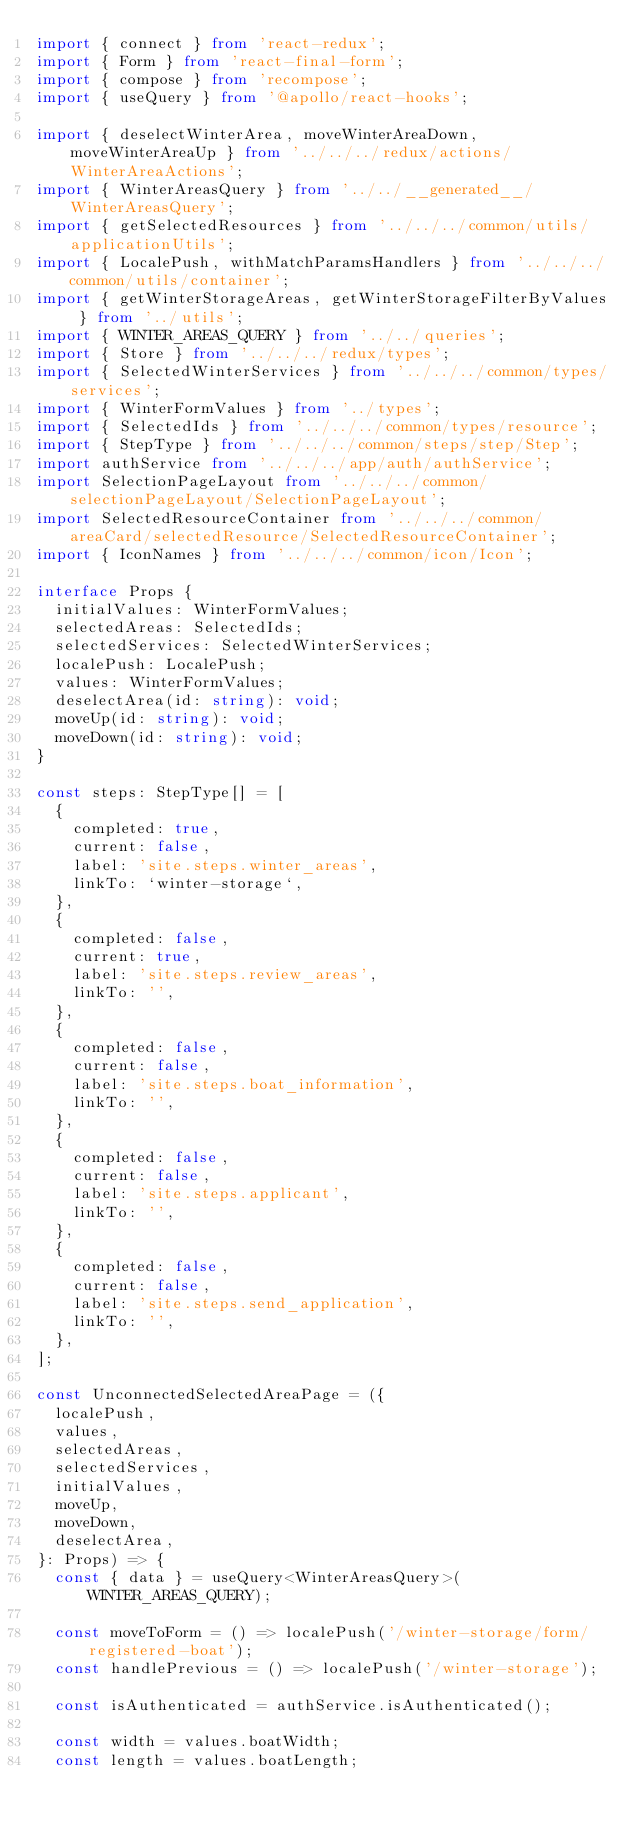Convert code to text. <code><loc_0><loc_0><loc_500><loc_500><_TypeScript_>import { connect } from 'react-redux';
import { Form } from 'react-final-form';
import { compose } from 'recompose';
import { useQuery } from '@apollo/react-hooks';

import { deselectWinterArea, moveWinterAreaDown, moveWinterAreaUp } from '../../../redux/actions/WinterAreaActions';
import { WinterAreasQuery } from '../../__generated__/WinterAreasQuery';
import { getSelectedResources } from '../../../common/utils/applicationUtils';
import { LocalePush, withMatchParamsHandlers } from '../../../common/utils/container';
import { getWinterStorageAreas, getWinterStorageFilterByValues } from '../utils';
import { WINTER_AREAS_QUERY } from '../../queries';
import { Store } from '../../../redux/types';
import { SelectedWinterServices } from '../../../common/types/services';
import { WinterFormValues } from '../types';
import { SelectedIds } from '../../../common/types/resource';
import { StepType } from '../../../common/steps/step/Step';
import authService from '../../../app/auth/authService';
import SelectionPageLayout from '../../../common/selectionPageLayout/SelectionPageLayout';
import SelectedResourceContainer from '../../../common/areaCard/selectedResource/SelectedResourceContainer';
import { IconNames } from '../../../common/icon/Icon';

interface Props {
  initialValues: WinterFormValues;
  selectedAreas: SelectedIds;
  selectedServices: SelectedWinterServices;
  localePush: LocalePush;
  values: WinterFormValues;
  deselectArea(id: string): void;
  moveUp(id: string): void;
  moveDown(id: string): void;
}

const steps: StepType[] = [
  {
    completed: true,
    current: false,
    label: 'site.steps.winter_areas',
    linkTo: `winter-storage`,
  },
  {
    completed: false,
    current: true,
    label: 'site.steps.review_areas',
    linkTo: '',
  },
  {
    completed: false,
    current: false,
    label: 'site.steps.boat_information',
    linkTo: '',
  },
  {
    completed: false,
    current: false,
    label: 'site.steps.applicant',
    linkTo: '',
  },
  {
    completed: false,
    current: false,
    label: 'site.steps.send_application',
    linkTo: '',
  },
];

const UnconnectedSelectedAreaPage = ({
  localePush,
  values,
  selectedAreas,
  selectedServices,
  initialValues,
  moveUp,
  moveDown,
  deselectArea,
}: Props) => {
  const { data } = useQuery<WinterAreasQuery>(WINTER_AREAS_QUERY);

  const moveToForm = () => localePush('/winter-storage/form/registered-boat');
  const handlePrevious = () => localePush('/winter-storage');

  const isAuthenticated = authService.isAuthenticated();

  const width = values.boatWidth;
  const length = values.boatLength;</code> 